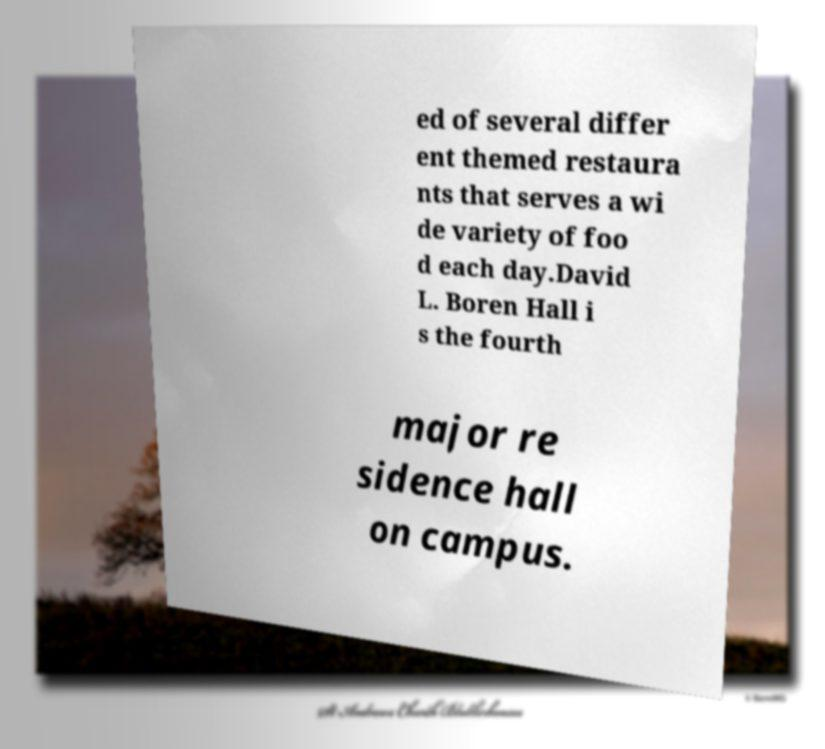Please read and relay the text visible in this image. What does it say? ed of several differ ent themed restaura nts that serves a wi de variety of foo d each day.David L. Boren Hall i s the fourth major re sidence hall on campus. 